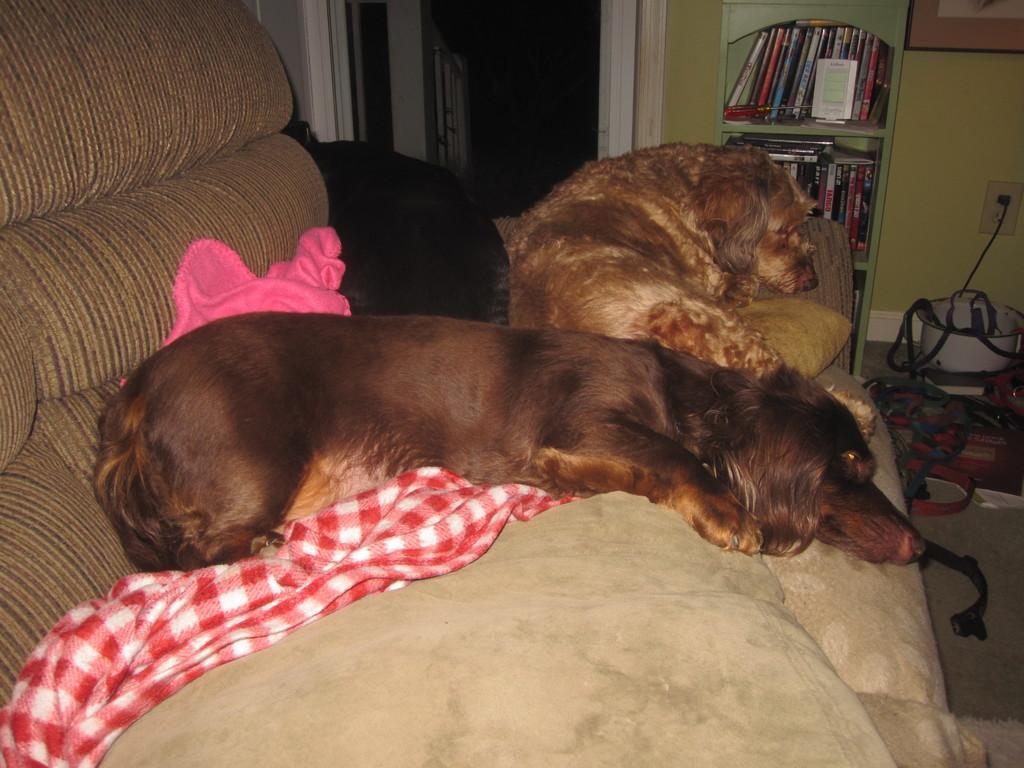Can you describe this image briefly? In the picture we can see a sofa which is cream in color and on it we can see two dogs are sleeping, one is brown in color and one is gold in color and beside the sofa we can see a door which is opened and beside it, we can see a rack with books and beside it we can see a bowl with wires connected to the switch and to the wall we can see a photo frame. 